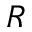Convert formula to latex. <formula><loc_0><loc_0><loc_500><loc_500>R</formula> 